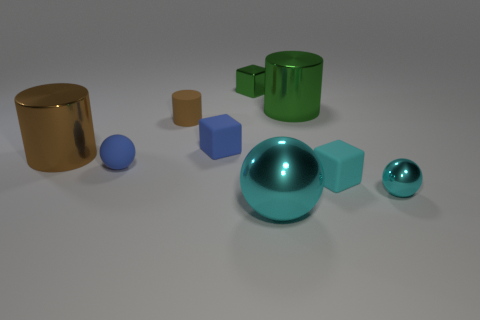What color is the rubber cylinder?
Offer a terse response. Brown. There is a big metallic thing in front of the big brown metal cylinder; is it the same shape as the large thing that is on the right side of the large cyan object?
Offer a very short reply. No. There is a shiny cylinder that is to the left of the tiny brown cylinder; what is its color?
Offer a very short reply. Brown. Are there fewer small blue balls that are left of the big brown metallic thing than tiny blue cubes that are behind the small cyan matte cube?
Provide a short and direct response. Yes. How many other objects are there of the same material as the large cyan thing?
Ensure brevity in your answer.  4. Does the large cyan sphere have the same material as the green cylinder?
Your answer should be very brief. Yes. How many other objects are there of the same size as the blue block?
Your response must be concise. 5. What is the size of the sphere that is on the right side of the tiny block right of the tiny green block?
Your answer should be very brief. Small. The tiny metallic thing that is behind the big shiny cylinder that is in front of the small rubber cube to the left of the green shiny cylinder is what color?
Your response must be concise. Green. What size is the thing that is behind the tiny cyan block and right of the large cyan object?
Your answer should be compact. Large. 